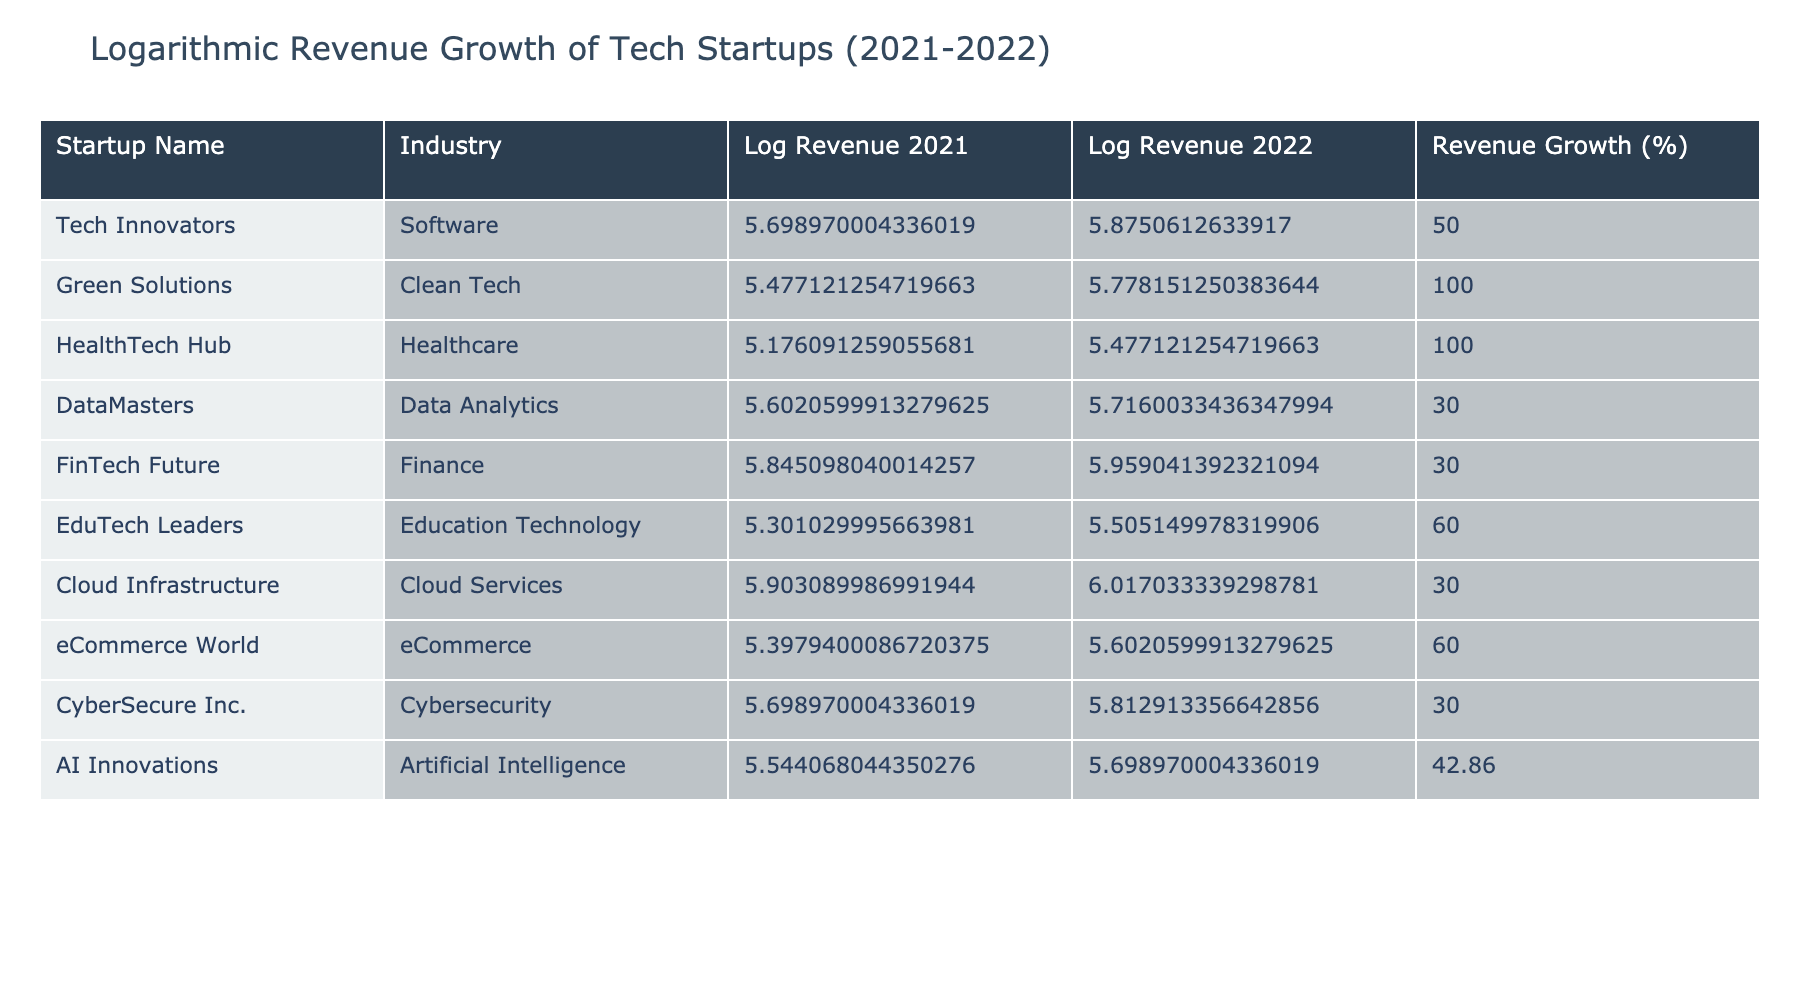What is the revenue growth percentage of Green Solutions? The revenue growth percentage for Green Solutions is explicitly stated in the table under the "Revenue Growth (%)" column, which shows 100% for this startup.
Answer: 100% Which startup had the highest revenue in 2022? To find this, we look at the "Revenue 2022 (USD)" column and identify the maximum value. Cloud Infrastructure has the highest revenue at 1,040,000 USD.
Answer: Cloud Infrastructure What is the average revenue growth percentage of all the startups listed? First, we sum up all the revenue growth percentages: 50 + 100 + 100 + 30 + 30 + 60 + 30 + 60 + 30 + 42.86 = 572.86. Then we divide by the number of startups (10): 572.86 / 10 = 57.286. So the average revenue growth percentage is approximately 57.29%.
Answer: 57.29% Is it true that all startups in the table experienced revenue growth in 2022? We can check the revenue growth percentages. All startups have positive percentages listed, indicating that they all achieved revenue growth compared to 2021.
Answer: Yes Which industry experienced the least revenue growth percentage, and what was it? We review the revenue growth percentages across industries. DataMasters, FinTech Future, CyberSecure Inc., and AI Innovations each have a revenue growth percentage of 30%, which is the lowest amongst all.
Answer: Data Analytics, 30% What is the total revenue of all startups combined for 2022? We sum the "Revenue 2022 (USD)" values: 750000 + 600000 + 300000 + 520000 + 910000 + 320000 + 1040000 + 400000 + 650000 + 500000 = 5,780,000 USD. Therefore, the total revenue for all startups in 2022 is 5,780,000 USD.
Answer: 5,780,000 USD Which startup had the highest revenue in 2021? Looking closely at the "Revenue 2021 (USD)" column, we see that FinTech Future had the highest revenue at 700,000 USD in 2021.
Answer: FinTech Future How much more revenue did Cloud Infrastructure generate in 2022 compared to 2021? To find this, we need to subtract the 2021 revenue from the 2022 revenue for Cloud Infrastructure: 1,040,000 - 800,000 = 240,000. Thus, Cloud Infrastructure generated 240,000 USD more in 2022 than in 2021.
Answer: 240,000 USD 